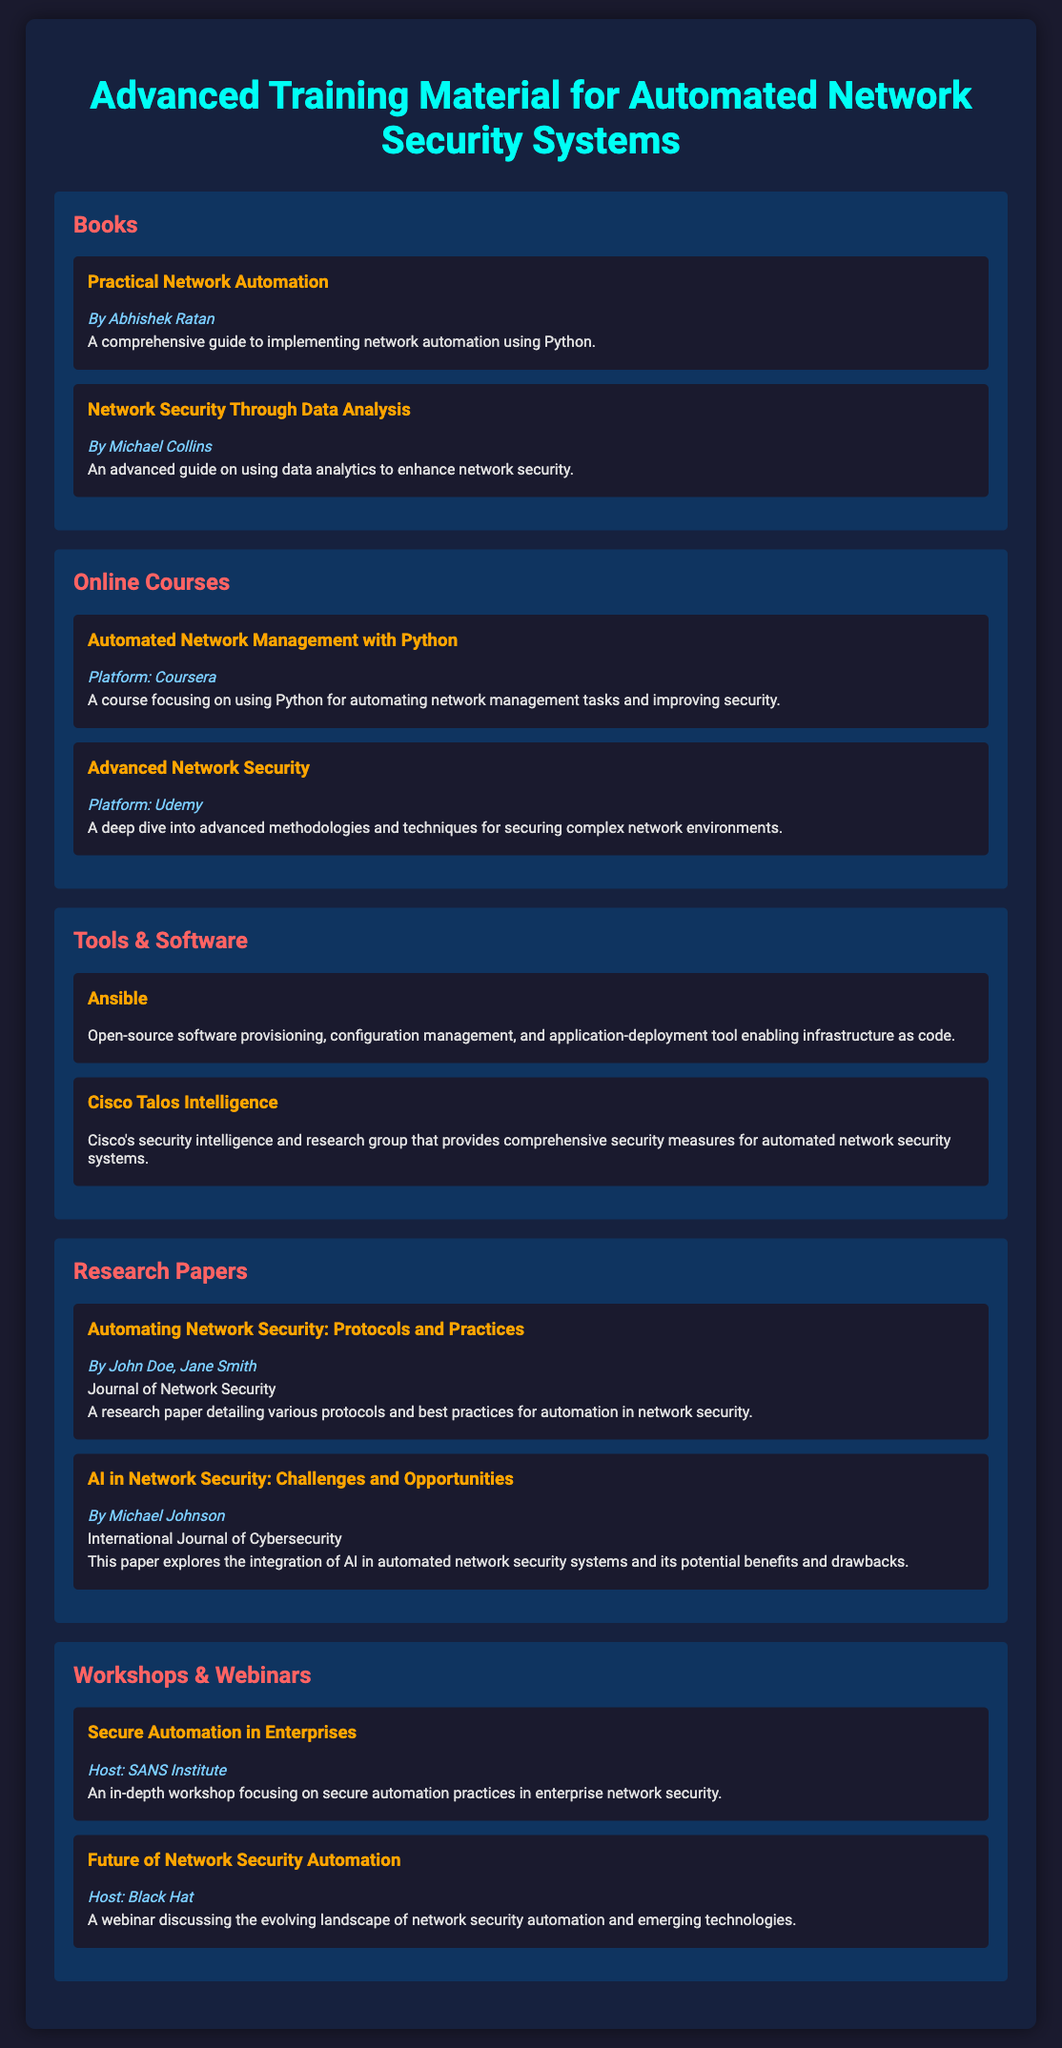What is the title of the first book listed? The title of the first book can be found in the "Books" category, which is "Practical Network Automation."
Answer: Practical Network Automation Who is the author of "Network Security Through Data Analysis"? The author is mentioned below the book title in the "Books" category, which states "By Michael Collins."
Answer: Michael Collins What platform is the course "Automated Network Management with Python" offered on? The platform is specified in the "Online Courses" category, mentioning "Platform: Coursera."
Answer: Coursera What is the focus of the "Ansible" tool listed? The focus is described in the "Tools & Software" category, where it is characterized as a tool for infrastructure as code.
Answer: Infrastructure as code Which two authors wrote the paper "Automating Network Security: Protocols and Practices"? The authors are listed at the beginning of the item in the "Research Papers" category: "By John Doe, Jane Smith."
Answer: John Doe, Jane Smith Who is hosting the workshop on secure automation? The host's name is provided in the "Workshops & Webinars" category, which says "Host: SANS Institute."
Answer: SANS Institute What is the main topic of the webinar "Future of Network Security Automation"? The topic is indicated in the description of the item within the "Workshops & Webinars" category.
Answer: Evolving landscape of network security automation Which item describes a comprehensive guide on using data analytics? This information can be retrieved from the title and description in the "Books" category about the second book listed.
Answer: Network Security Through Data Analysis How many items are listed under the "Tools & Software" category? This can be determined by counting the number of items in that section; there are two items listed.
Answer: 2 